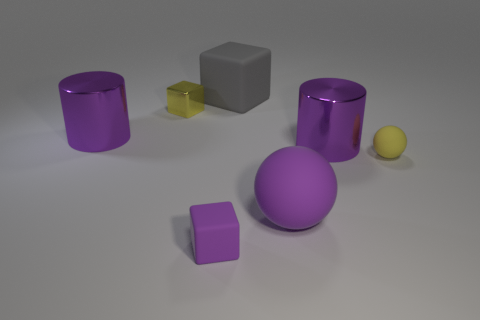Is the number of blocks that are in front of the tiny yellow block greater than the number of gray things that are in front of the tiny matte ball?
Offer a very short reply. Yes. The purple matte thing that is the same shape as the yellow metallic thing is what size?
Make the answer very short. Small. What number of cubes are small purple matte objects or big objects?
Offer a very short reply. 2. What material is the ball that is the same color as the small metallic block?
Your answer should be compact. Rubber. Is the number of purple cubes that are in front of the tiny purple block less than the number of metal things that are on the right side of the tiny metal thing?
Make the answer very short. Yes. What number of objects are either metallic things that are to the left of the small yellow metal cube or large green shiny cubes?
Your answer should be compact. 1. The shiny object that is in front of the large purple cylinder that is to the left of the small shiny thing is what shape?
Give a very brief answer. Cylinder. Are there any purple matte spheres of the same size as the purple matte block?
Your response must be concise. No. Are there more large gray cylinders than small purple rubber blocks?
Make the answer very short. No. Does the block in front of the yellow sphere have the same size as the matte cube behind the tiny metallic block?
Offer a very short reply. No. 